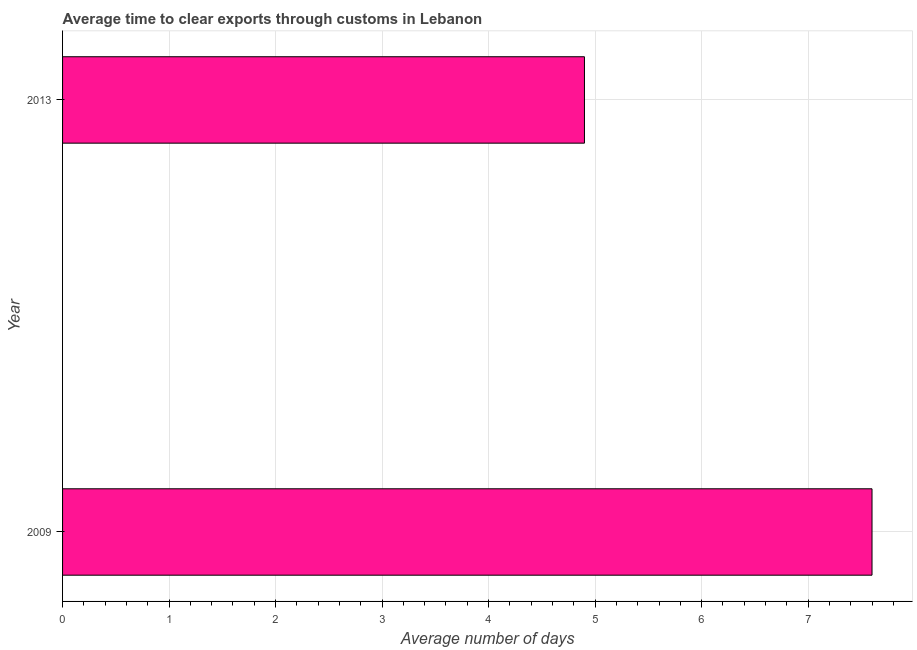What is the title of the graph?
Give a very brief answer. Average time to clear exports through customs in Lebanon. What is the label or title of the X-axis?
Offer a very short reply. Average number of days. What is the time to clear exports through customs in 2009?
Your answer should be compact. 7.6. In which year was the time to clear exports through customs minimum?
Provide a short and direct response. 2013. What is the average time to clear exports through customs per year?
Provide a short and direct response. 6.25. What is the median time to clear exports through customs?
Offer a very short reply. 6.25. In how many years, is the time to clear exports through customs greater than 6.2 days?
Your answer should be compact. 1. What is the ratio of the time to clear exports through customs in 2009 to that in 2013?
Your answer should be very brief. 1.55. Is the time to clear exports through customs in 2009 less than that in 2013?
Ensure brevity in your answer.  No. How many years are there in the graph?
Offer a very short reply. 2. Are the values on the major ticks of X-axis written in scientific E-notation?
Make the answer very short. No. What is the Average number of days in 2009?
Your answer should be compact. 7.6. What is the Average number of days in 2013?
Offer a terse response. 4.9. What is the difference between the Average number of days in 2009 and 2013?
Provide a short and direct response. 2.7. What is the ratio of the Average number of days in 2009 to that in 2013?
Provide a short and direct response. 1.55. 